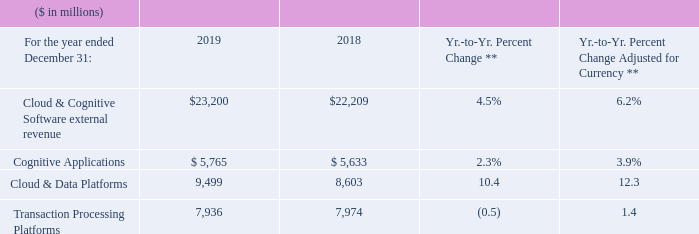Cloud & Cognitive Software
* Recast to reflect segment changes.
** 2019 results were impacted by Red Hat purchase accounting.
Cloud & Cognitive Software revenue of $23,200 million increased 4.5 percent as reported (6 percent adjusted for currency) in 2019 compared to the prior year. There was strong growth in Cloud & Data Platforms, as reported and at constant currency, driven primarily by the acquisition of Red Hat in the third quarter of 2019. Red Hat had continued strong performance since the acquisition, in Red Hat Enterprise Linux (RHEL), application development and emerging technologies, led by OpenShift and Ansible. Red Hat and IBM are driving synergies with strong adoption of Cloud Paks since their introduction, expansion of our combined client base and more than 2,000 clients using our hybrid cloud platform. Cognitive Applications also grew as reported and at constant currency. Transaction Processing Platforms declined year to year as reported, but grew 1 percent adjusted for currency driven by strong fourth-quarter performance.
Cognitive Applications revenue of $5,765 million grew 2.3 percent as reported (4 percent adjusted for currency) compared to the prior year, driven by double-digit growth as reported and adjusted for currency in Security, and growth in industry verticals such as IoT. The Security performance included continued strong results in threat management software and services offerings. Within IoT, we had good revenue performance across the portfolio as we continued to invest in new offerings and industry-specific solutions.
Cloud & Data Platforms revenue of $9,499 million increased 10.4 percent as reported (12 percent adjusted for currency) compared to the prior year. Performance was driven by the addition of RHEL and OpenShift and the continued execution of the combined Red Hat and IBM hybrid strategy.
Transaction Processing Platforms revenue of $7,936 million decreased 0.5 percent as reported, but grew 1 percent adjusted for currency in 2019, compared to the prior year. Revenue performance reflects the ongoing investment in IBM platforms, and the timing of larger transactions that are tied to client business volumes and buying cycles.
Within Cloud & Cognitive Software, cloud revenue of $4.2 billion grew 40 percent as reported and 42 percent adjusted for currency year to year, reflecting the acquisition of Red Hat and client adoption of our hybrid cloud offerings.
What caused the increase in Cloud & Cognitive Software revenue in 2019? There was strong growth in cloud & data platforms, as reported and at constant currency, driven primarily by the acquisition of red hat in the third quarter of 2019. red hat had continued strong performance since the acquisition, in red hat enterprise linux (rhel), application development and emerging technologies, led by openshift and ansible. What caused the increase in Cognitive Applications revenue in 2019? Driven by double-digit growth as reported and adjusted for currency in security, and growth in industry verticals such as iot. What caused the increase in Cloud & Data Platforms revenue in 2019? Performance was driven by the addition of rhel and openshift and the continued execution of the combined red hat and ibm hybrid strategy. What was the average Cloud & Cognitive Software external revenue in 2019 and 2018?
Answer scale should be: million. (23,200 + 22,209) / 2
Answer: 22704.5. What percentage of Cloud & Cognitive Software external revenue was Transaction Processing Platforms in 2019?
Answer scale should be: percent. 7,936 / 23,200
Answer: 34.21. What is the average of Cloud & Data Platforms in 2019 and 2018?
Answer scale should be: million. (9,499 + 8,603) / 2
Answer: 9051. 